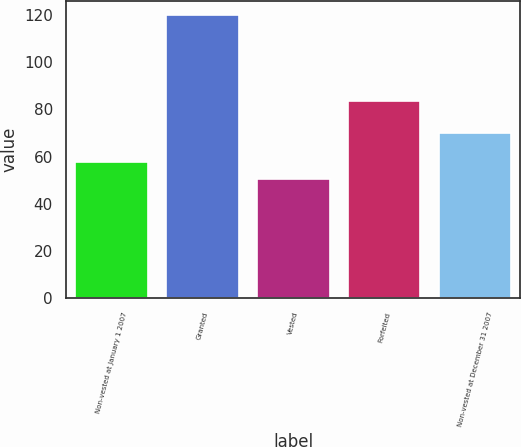Convert chart to OTSL. <chart><loc_0><loc_0><loc_500><loc_500><bar_chart><fcel>Non-vested at January 1 2007<fcel>Granted<fcel>Vested<fcel>Forfeited<fcel>Non-vested at December 31 2007<nl><fcel>57.83<fcel>119.86<fcel>50.32<fcel>83.72<fcel>70.07<nl></chart> 